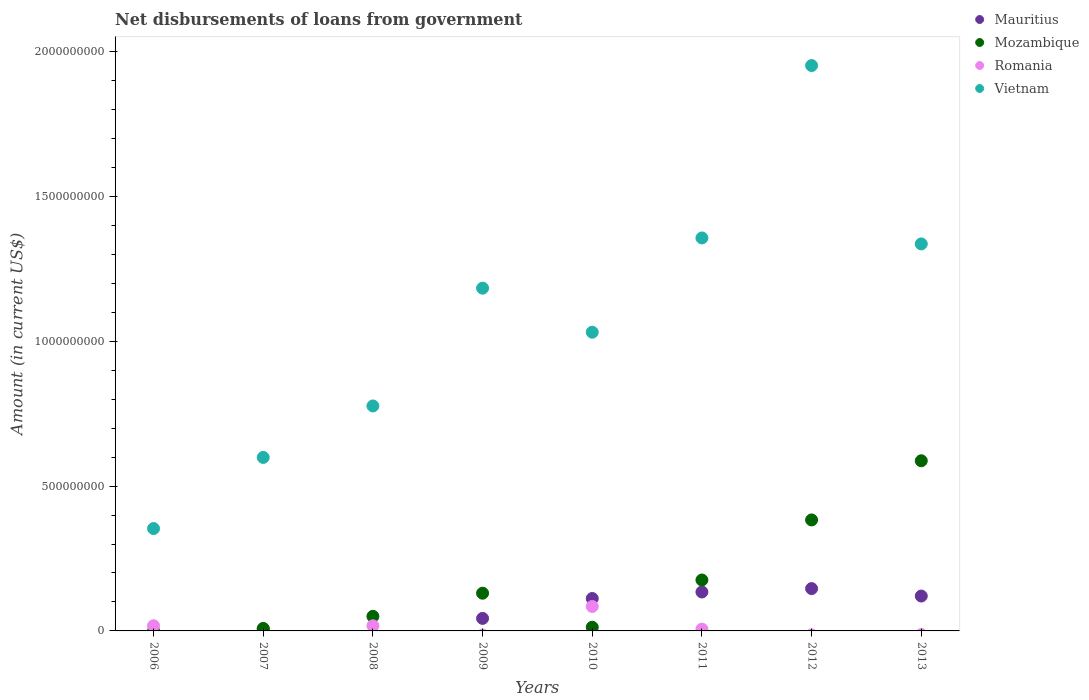What is the amount of loan disbursed from government in Vietnam in 2007?
Give a very brief answer. 5.99e+08. Across all years, what is the maximum amount of loan disbursed from government in Romania?
Offer a terse response. 8.44e+07. Across all years, what is the minimum amount of loan disbursed from government in Mozambique?
Give a very brief answer. 0. What is the total amount of loan disbursed from government in Romania in the graph?
Make the answer very short. 1.26e+08. What is the difference between the amount of loan disbursed from government in Vietnam in 2009 and that in 2011?
Give a very brief answer. -1.73e+08. What is the difference between the amount of loan disbursed from government in Vietnam in 2013 and the amount of loan disbursed from government in Romania in 2008?
Offer a terse response. 1.32e+09. What is the average amount of loan disbursed from government in Mozambique per year?
Keep it short and to the point. 1.69e+08. In the year 2006, what is the difference between the amount of loan disbursed from government in Vietnam and amount of loan disbursed from government in Romania?
Ensure brevity in your answer.  3.36e+08. In how many years, is the amount of loan disbursed from government in Mozambique greater than 600000000 US$?
Provide a succinct answer. 0. What is the ratio of the amount of loan disbursed from government in Vietnam in 2008 to that in 2009?
Offer a very short reply. 0.66. What is the difference between the highest and the second highest amount of loan disbursed from government in Mauritius?
Your answer should be compact. 1.17e+07. What is the difference between the highest and the lowest amount of loan disbursed from government in Mozambique?
Give a very brief answer. 5.87e+08. In how many years, is the amount of loan disbursed from government in Mauritius greater than the average amount of loan disbursed from government in Mauritius taken over all years?
Offer a very short reply. 4. Is it the case that in every year, the sum of the amount of loan disbursed from government in Mauritius and amount of loan disbursed from government in Mozambique  is greater than the sum of amount of loan disbursed from government in Romania and amount of loan disbursed from government in Vietnam?
Your answer should be very brief. No. Is the amount of loan disbursed from government in Mauritius strictly greater than the amount of loan disbursed from government in Mozambique over the years?
Offer a terse response. No. How many dotlines are there?
Provide a succinct answer. 4. How many years are there in the graph?
Provide a short and direct response. 8. Are the values on the major ticks of Y-axis written in scientific E-notation?
Keep it short and to the point. No. How many legend labels are there?
Your answer should be very brief. 4. How are the legend labels stacked?
Keep it short and to the point. Vertical. What is the title of the graph?
Offer a very short reply. Net disbursements of loans from government. Does "Northern Mariana Islands" appear as one of the legend labels in the graph?
Keep it short and to the point. No. What is the Amount (in current US$) in Mauritius in 2006?
Provide a short and direct response. 0. What is the Amount (in current US$) in Romania in 2006?
Offer a very short reply. 1.79e+07. What is the Amount (in current US$) in Vietnam in 2006?
Ensure brevity in your answer.  3.53e+08. What is the Amount (in current US$) in Mauritius in 2007?
Your answer should be very brief. 6.59e+06. What is the Amount (in current US$) of Mozambique in 2007?
Your answer should be very brief. 8.58e+06. What is the Amount (in current US$) of Vietnam in 2007?
Your answer should be very brief. 5.99e+08. What is the Amount (in current US$) of Mozambique in 2008?
Provide a succinct answer. 5.03e+07. What is the Amount (in current US$) in Romania in 2008?
Your answer should be very brief. 1.78e+07. What is the Amount (in current US$) of Vietnam in 2008?
Give a very brief answer. 7.77e+08. What is the Amount (in current US$) in Mauritius in 2009?
Keep it short and to the point. 4.32e+07. What is the Amount (in current US$) of Mozambique in 2009?
Your response must be concise. 1.30e+08. What is the Amount (in current US$) in Romania in 2009?
Your answer should be compact. 0. What is the Amount (in current US$) in Vietnam in 2009?
Your answer should be compact. 1.18e+09. What is the Amount (in current US$) of Mauritius in 2010?
Provide a short and direct response. 1.12e+08. What is the Amount (in current US$) in Mozambique in 2010?
Ensure brevity in your answer.  1.27e+07. What is the Amount (in current US$) in Romania in 2010?
Offer a terse response. 8.44e+07. What is the Amount (in current US$) in Vietnam in 2010?
Provide a short and direct response. 1.03e+09. What is the Amount (in current US$) of Mauritius in 2011?
Provide a short and direct response. 1.34e+08. What is the Amount (in current US$) in Mozambique in 2011?
Provide a short and direct response. 1.76e+08. What is the Amount (in current US$) in Romania in 2011?
Provide a succinct answer. 6.24e+06. What is the Amount (in current US$) in Vietnam in 2011?
Provide a succinct answer. 1.36e+09. What is the Amount (in current US$) in Mauritius in 2012?
Your answer should be very brief. 1.46e+08. What is the Amount (in current US$) of Mozambique in 2012?
Give a very brief answer. 3.83e+08. What is the Amount (in current US$) in Vietnam in 2012?
Give a very brief answer. 1.95e+09. What is the Amount (in current US$) of Mauritius in 2013?
Keep it short and to the point. 1.20e+08. What is the Amount (in current US$) of Mozambique in 2013?
Make the answer very short. 5.87e+08. What is the Amount (in current US$) in Romania in 2013?
Your response must be concise. 0. What is the Amount (in current US$) of Vietnam in 2013?
Provide a short and direct response. 1.34e+09. Across all years, what is the maximum Amount (in current US$) in Mauritius?
Provide a succinct answer. 1.46e+08. Across all years, what is the maximum Amount (in current US$) of Mozambique?
Ensure brevity in your answer.  5.87e+08. Across all years, what is the maximum Amount (in current US$) in Romania?
Your response must be concise. 8.44e+07. Across all years, what is the maximum Amount (in current US$) of Vietnam?
Keep it short and to the point. 1.95e+09. Across all years, what is the minimum Amount (in current US$) of Mozambique?
Keep it short and to the point. 0. Across all years, what is the minimum Amount (in current US$) in Vietnam?
Provide a succinct answer. 3.53e+08. What is the total Amount (in current US$) in Mauritius in the graph?
Offer a very short reply. 5.63e+08. What is the total Amount (in current US$) of Mozambique in the graph?
Ensure brevity in your answer.  1.35e+09. What is the total Amount (in current US$) of Romania in the graph?
Your answer should be compact. 1.26e+08. What is the total Amount (in current US$) of Vietnam in the graph?
Make the answer very short. 8.59e+09. What is the difference between the Amount (in current US$) of Vietnam in 2006 and that in 2007?
Offer a very short reply. -2.46e+08. What is the difference between the Amount (in current US$) in Romania in 2006 and that in 2008?
Your response must be concise. 7.40e+04. What is the difference between the Amount (in current US$) of Vietnam in 2006 and that in 2008?
Your answer should be very brief. -4.23e+08. What is the difference between the Amount (in current US$) of Vietnam in 2006 and that in 2009?
Give a very brief answer. -8.30e+08. What is the difference between the Amount (in current US$) in Romania in 2006 and that in 2010?
Your response must be concise. -6.65e+07. What is the difference between the Amount (in current US$) in Vietnam in 2006 and that in 2010?
Provide a succinct answer. -6.78e+08. What is the difference between the Amount (in current US$) in Romania in 2006 and that in 2011?
Give a very brief answer. 1.16e+07. What is the difference between the Amount (in current US$) of Vietnam in 2006 and that in 2011?
Ensure brevity in your answer.  -1.00e+09. What is the difference between the Amount (in current US$) of Vietnam in 2006 and that in 2012?
Provide a succinct answer. -1.60e+09. What is the difference between the Amount (in current US$) of Vietnam in 2006 and that in 2013?
Give a very brief answer. -9.83e+08. What is the difference between the Amount (in current US$) in Mozambique in 2007 and that in 2008?
Give a very brief answer. -4.17e+07. What is the difference between the Amount (in current US$) of Vietnam in 2007 and that in 2008?
Your answer should be very brief. -1.78e+08. What is the difference between the Amount (in current US$) in Mauritius in 2007 and that in 2009?
Provide a succinct answer. -3.67e+07. What is the difference between the Amount (in current US$) in Mozambique in 2007 and that in 2009?
Offer a very short reply. -1.22e+08. What is the difference between the Amount (in current US$) of Vietnam in 2007 and that in 2009?
Offer a terse response. -5.84e+08. What is the difference between the Amount (in current US$) in Mauritius in 2007 and that in 2010?
Offer a terse response. -1.05e+08. What is the difference between the Amount (in current US$) in Mozambique in 2007 and that in 2010?
Provide a short and direct response. -4.10e+06. What is the difference between the Amount (in current US$) of Vietnam in 2007 and that in 2010?
Ensure brevity in your answer.  -4.32e+08. What is the difference between the Amount (in current US$) in Mauritius in 2007 and that in 2011?
Keep it short and to the point. -1.28e+08. What is the difference between the Amount (in current US$) in Mozambique in 2007 and that in 2011?
Offer a very short reply. -1.67e+08. What is the difference between the Amount (in current US$) in Vietnam in 2007 and that in 2011?
Keep it short and to the point. -7.58e+08. What is the difference between the Amount (in current US$) of Mauritius in 2007 and that in 2012?
Provide a short and direct response. -1.40e+08. What is the difference between the Amount (in current US$) of Mozambique in 2007 and that in 2012?
Provide a succinct answer. -3.75e+08. What is the difference between the Amount (in current US$) in Vietnam in 2007 and that in 2012?
Provide a short and direct response. -1.35e+09. What is the difference between the Amount (in current US$) of Mauritius in 2007 and that in 2013?
Your answer should be very brief. -1.14e+08. What is the difference between the Amount (in current US$) in Mozambique in 2007 and that in 2013?
Offer a very short reply. -5.79e+08. What is the difference between the Amount (in current US$) of Vietnam in 2007 and that in 2013?
Your answer should be compact. -7.37e+08. What is the difference between the Amount (in current US$) of Mozambique in 2008 and that in 2009?
Your answer should be very brief. -7.99e+07. What is the difference between the Amount (in current US$) in Vietnam in 2008 and that in 2009?
Make the answer very short. -4.07e+08. What is the difference between the Amount (in current US$) of Mozambique in 2008 and that in 2010?
Offer a very short reply. 3.76e+07. What is the difference between the Amount (in current US$) of Romania in 2008 and that in 2010?
Offer a terse response. -6.66e+07. What is the difference between the Amount (in current US$) in Vietnam in 2008 and that in 2010?
Offer a terse response. -2.55e+08. What is the difference between the Amount (in current US$) in Mozambique in 2008 and that in 2011?
Your answer should be compact. -1.26e+08. What is the difference between the Amount (in current US$) of Romania in 2008 and that in 2011?
Your answer should be very brief. 1.15e+07. What is the difference between the Amount (in current US$) in Vietnam in 2008 and that in 2011?
Your answer should be very brief. -5.80e+08. What is the difference between the Amount (in current US$) in Mozambique in 2008 and that in 2012?
Your answer should be very brief. -3.33e+08. What is the difference between the Amount (in current US$) in Vietnam in 2008 and that in 2012?
Provide a short and direct response. -1.18e+09. What is the difference between the Amount (in current US$) in Mozambique in 2008 and that in 2013?
Offer a very short reply. -5.37e+08. What is the difference between the Amount (in current US$) of Vietnam in 2008 and that in 2013?
Your response must be concise. -5.59e+08. What is the difference between the Amount (in current US$) in Mauritius in 2009 and that in 2010?
Give a very brief answer. -6.87e+07. What is the difference between the Amount (in current US$) of Mozambique in 2009 and that in 2010?
Provide a short and direct response. 1.18e+08. What is the difference between the Amount (in current US$) in Vietnam in 2009 and that in 2010?
Offer a terse response. 1.52e+08. What is the difference between the Amount (in current US$) of Mauritius in 2009 and that in 2011?
Give a very brief answer. -9.11e+07. What is the difference between the Amount (in current US$) of Mozambique in 2009 and that in 2011?
Keep it short and to the point. -4.56e+07. What is the difference between the Amount (in current US$) of Vietnam in 2009 and that in 2011?
Make the answer very short. -1.73e+08. What is the difference between the Amount (in current US$) in Mauritius in 2009 and that in 2012?
Your response must be concise. -1.03e+08. What is the difference between the Amount (in current US$) of Mozambique in 2009 and that in 2012?
Your answer should be compact. -2.53e+08. What is the difference between the Amount (in current US$) of Vietnam in 2009 and that in 2012?
Give a very brief answer. -7.69e+08. What is the difference between the Amount (in current US$) in Mauritius in 2009 and that in 2013?
Keep it short and to the point. -7.72e+07. What is the difference between the Amount (in current US$) in Mozambique in 2009 and that in 2013?
Keep it short and to the point. -4.57e+08. What is the difference between the Amount (in current US$) in Vietnam in 2009 and that in 2013?
Your answer should be very brief. -1.53e+08. What is the difference between the Amount (in current US$) in Mauritius in 2010 and that in 2011?
Give a very brief answer. -2.24e+07. What is the difference between the Amount (in current US$) of Mozambique in 2010 and that in 2011?
Give a very brief answer. -1.63e+08. What is the difference between the Amount (in current US$) in Romania in 2010 and that in 2011?
Provide a succinct answer. 7.82e+07. What is the difference between the Amount (in current US$) in Vietnam in 2010 and that in 2011?
Your answer should be compact. -3.25e+08. What is the difference between the Amount (in current US$) of Mauritius in 2010 and that in 2012?
Your answer should be compact. -3.41e+07. What is the difference between the Amount (in current US$) of Mozambique in 2010 and that in 2012?
Your answer should be compact. -3.71e+08. What is the difference between the Amount (in current US$) of Vietnam in 2010 and that in 2012?
Ensure brevity in your answer.  -9.21e+08. What is the difference between the Amount (in current US$) of Mauritius in 2010 and that in 2013?
Offer a very short reply. -8.45e+06. What is the difference between the Amount (in current US$) in Mozambique in 2010 and that in 2013?
Ensure brevity in your answer.  -5.75e+08. What is the difference between the Amount (in current US$) in Vietnam in 2010 and that in 2013?
Offer a very short reply. -3.05e+08. What is the difference between the Amount (in current US$) of Mauritius in 2011 and that in 2012?
Provide a short and direct response. -1.17e+07. What is the difference between the Amount (in current US$) of Mozambique in 2011 and that in 2012?
Offer a very short reply. -2.07e+08. What is the difference between the Amount (in current US$) of Vietnam in 2011 and that in 2012?
Make the answer very short. -5.95e+08. What is the difference between the Amount (in current US$) in Mauritius in 2011 and that in 2013?
Offer a very short reply. 1.40e+07. What is the difference between the Amount (in current US$) of Mozambique in 2011 and that in 2013?
Provide a succinct answer. -4.12e+08. What is the difference between the Amount (in current US$) in Vietnam in 2011 and that in 2013?
Offer a very short reply. 2.06e+07. What is the difference between the Amount (in current US$) of Mauritius in 2012 and that in 2013?
Give a very brief answer. 2.57e+07. What is the difference between the Amount (in current US$) in Mozambique in 2012 and that in 2013?
Offer a terse response. -2.04e+08. What is the difference between the Amount (in current US$) of Vietnam in 2012 and that in 2013?
Offer a terse response. 6.16e+08. What is the difference between the Amount (in current US$) in Romania in 2006 and the Amount (in current US$) in Vietnam in 2007?
Your answer should be very brief. -5.81e+08. What is the difference between the Amount (in current US$) in Romania in 2006 and the Amount (in current US$) in Vietnam in 2008?
Ensure brevity in your answer.  -7.59e+08. What is the difference between the Amount (in current US$) of Romania in 2006 and the Amount (in current US$) of Vietnam in 2009?
Provide a short and direct response. -1.17e+09. What is the difference between the Amount (in current US$) in Romania in 2006 and the Amount (in current US$) in Vietnam in 2010?
Offer a very short reply. -1.01e+09. What is the difference between the Amount (in current US$) in Romania in 2006 and the Amount (in current US$) in Vietnam in 2011?
Make the answer very short. -1.34e+09. What is the difference between the Amount (in current US$) in Romania in 2006 and the Amount (in current US$) in Vietnam in 2012?
Your answer should be compact. -1.93e+09. What is the difference between the Amount (in current US$) in Romania in 2006 and the Amount (in current US$) in Vietnam in 2013?
Make the answer very short. -1.32e+09. What is the difference between the Amount (in current US$) in Mauritius in 2007 and the Amount (in current US$) in Mozambique in 2008?
Your response must be concise. -4.37e+07. What is the difference between the Amount (in current US$) of Mauritius in 2007 and the Amount (in current US$) of Romania in 2008?
Keep it short and to the point. -1.12e+07. What is the difference between the Amount (in current US$) of Mauritius in 2007 and the Amount (in current US$) of Vietnam in 2008?
Offer a very short reply. -7.70e+08. What is the difference between the Amount (in current US$) of Mozambique in 2007 and the Amount (in current US$) of Romania in 2008?
Provide a short and direct response. -9.20e+06. What is the difference between the Amount (in current US$) of Mozambique in 2007 and the Amount (in current US$) of Vietnam in 2008?
Provide a succinct answer. -7.68e+08. What is the difference between the Amount (in current US$) in Mauritius in 2007 and the Amount (in current US$) in Mozambique in 2009?
Ensure brevity in your answer.  -1.24e+08. What is the difference between the Amount (in current US$) of Mauritius in 2007 and the Amount (in current US$) of Vietnam in 2009?
Your answer should be very brief. -1.18e+09. What is the difference between the Amount (in current US$) in Mozambique in 2007 and the Amount (in current US$) in Vietnam in 2009?
Provide a succinct answer. -1.17e+09. What is the difference between the Amount (in current US$) in Mauritius in 2007 and the Amount (in current US$) in Mozambique in 2010?
Ensure brevity in your answer.  -6.09e+06. What is the difference between the Amount (in current US$) in Mauritius in 2007 and the Amount (in current US$) in Romania in 2010?
Your answer should be very brief. -7.78e+07. What is the difference between the Amount (in current US$) in Mauritius in 2007 and the Amount (in current US$) in Vietnam in 2010?
Offer a terse response. -1.02e+09. What is the difference between the Amount (in current US$) in Mozambique in 2007 and the Amount (in current US$) in Romania in 2010?
Offer a very short reply. -7.58e+07. What is the difference between the Amount (in current US$) in Mozambique in 2007 and the Amount (in current US$) in Vietnam in 2010?
Your response must be concise. -1.02e+09. What is the difference between the Amount (in current US$) of Mauritius in 2007 and the Amount (in current US$) of Mozambique in 2011?
Keep it short and to the point. -1.69e+08. What is the difference between the Amount (in current US$) in Mauritius in 2007 and the Amount (in current US$) in Romania in 2011?
Your response must be concise. 3.56e+05. What is the difference between the Amount (in current US$) in Mauritius in 2007 and the Amount (in current US$) in Vietnam in 2011?
Ensure brevity in your answer.  -1.35e+09. What is the difference between the Amount (in current US$) of Mozambique in 2007 and the Amount (in current US$) of Romania in 2011?
Give a very brief answer. 2.35e+06. What is the difference between the Amount (in current US$) in Mozambique in 2007 and the Amount (in current US$) in Vietnam in 2011?
Give a very brief answer. -1.35e+09. What is the difference between the Amount (in current US$) in Mauritius in 2007 and the Amount (in current US$) in Mozambique in 2012?
Offer a terse response. -3.77e+08. What is the difference between the Amount (in current US$) in Mauritius in 2007 and the Amount (in current US$) in Vietnam in 2012?
Give a very brief answer. -1.95e+09. What is the difference between the Amount (in current US$) of Mozambique in 2007 and the Amount (in current US$) of Vietnam in 2012?
Ensure brevity in your answer.  -1.94e+09. What is the difference between the Amount (in current US$) in Mauritius in 2007 and the Amount (in current US$) in Mozambique in 2013?
Give a very brief answer. -5.81e+08. What is the difference between the Amount (in current US$) of Mauritius in 2007 and the Amount (in current US$) of Vietnam in 2013?
Offer a very short reply. -1.33e+09. What is the difference between the Amount (in current US$) in Mozambique in 2007 and the Amount (in current US$) in Vietnam in 2013?
Make the answer very short. -1.33e+09. What is the difference between the Amount (in current US$) of Mozambique in 2008 and the Amount (in current US$) of Vietnam in 2009?
Make the answer very short. -1.13e+09. What is the difference between the Amount (in current US$) of Romania in 2008 and the Amount (in current US$) of Vietnam in 2009?
Provide a succinct answer. -1.17e+09. What is the difference between the Amount (in current US$) of Mozambique in 2008 and the Amount (in current US$) of Romania in 2010?
Give a very brief answer. -3.41e+07. What is the difference between the Amount (in current US$) in Mozambique in 2008 and the Amount (in current US$) in Vietnam in 2010?
Your answer should be compact. -9.81e+08. What is the difference between the Amount (in current US$) of Romania in 2008 and the Amount (in current US$) of Vietnam in 2010?
Your answer should be compact. -1.01e+09. What is the difference between the Amount (in current US$) in Mozambique in 2008 and the Amount (in current US$) in Romania in 2011?
Ensure brevity in your answer.  4.41e+07. What is the difference between the Amount (in current US$) in Mozambique in 2008 and the Amount (in current US$) in Vietnam in 2011?
Offer a terse response. -1.31e+09. What is the difference between the Amount (in current US$) in Romania in 2008 and the Amount (in current US$) in Vietnam in 2011?
Give a very brief answer. -1.34e+09. What is the difference between the Amount (in current US$) of Mozambique in 2008 and the Amount (in current US$) of Vietnam in 2012?
Your response must be concise. -1.90e+09. What is the difference between the Amount (in current US$) of Romania in 2008 and the Amount (in current US$) of Vietnam in 2012?
Provide a succinct answer. -1.93e+09. What is the difference between the Amount (in current US$) in Mozambique in 2008 and the Amount (in current US$) in Vietnam in 2013?
Make the answer very short. -1.29e+09. What is the difference between the Amount (in current US$) of Romania in 2008 and the Amount (in current US$) of Vietnam in 2013?
Provide a succinct answer. -1.32e+09. What is the difference between the Amount (in current US$) of Mauritius in 2009 and the Amount (in current US$) of Mozambique in 2010?
Your answer should be compact. 3.06e+07. What is the difference between the Amount (in current US$) of Mauritius in 2009 and the Amount (in current US$) of Romania in 2010?
Keep it short and to the point. -4.11e+07. What is the difference between the Amount (in current US$) of Mauritius in 2009 and the Amount (in current US$) of Vietnam in 2010?
Your answer should be very brief. -9.88e+08. What is the difference between the Amount (in current US$) in Mozambique in 2009 and the Amount (in current US$) in Romania in 2010?
Give a very brief answer. 4.58e+07. What is the difference between the Amount (in current US$) in Mozambique in 2009 and the Amount (in current US$) in Vietnam in 2010?
Your answer should be very brief. -9.01e+08. What is the difference between the Amount (in current US$) in Mauritius in 2009 and the Amount (in current US$) in Mozambique in 2011?
Make the answer very short. -1.33e+08. What is the difference between the Amount (in current US$) of Mauritius in 2009 and the Amount (in current US$) of Romania in 2011?
Ensure brevity in your answer.  3.70e+07. What is the difference between the Amount (in current US$) of Mauritius in 2009 and the Amount (in current US$) of Vietnam in 2011?
Offer a terse response. -1.31e+09. What is the difference between the Amount (in current US$) in Mozambique in 2009 and the Amount (in current US$) in Romania in 2011?
Provide a short and direct response. 1.24e+08. What is the difference between the Amount (in current US$) of Mozambique in 2009 and the Amount (in current US$) of Vietnam in 2011?
Provide a short and direct response. -1.23e+09. What is the difference between the Amount (in current US$) in Mauritius in 2009 and the Amount (in current US$) in Mozambique in 2012?
Provide a succinct answer. -3.40e+08. What is the difference between the Amount (in current US$) of Mauritius in 2009 and the Amount (in current US$) of Vietnam in 2012?
Ensure brevity in your answer.  -1.91e+09. What is the difference between the Amount (in current US$) in Mozambique in 2009 and the Amount (in current US$) in Vietnam in 2012?
Ensure brevity in your answer.  -1.82e+09. What is the difference between the Amount (in current US$) of Mauritius in 2009 and the Amount (in current US$) of Mozambique in 2013?
Keep it short and to the point. -5.44e+08. What is the difference between the Amount (in current US$) in Mauritius in 2009 and the Amount (in current US$) in Vietnam in 2013?
Ensure brevity in your answer.  -1.29e+09. What is the difference between the Amount (in current US$) of Mozambique in 2009 and the Amount (in current US$) of Vietnam in 2013?
Provide a succinct answer. -1.21e+09. What is the difference between the Amount (in current US$) of Mauritius in 2010 and the Amount (in current US$) of Mozambique in 2011?
Your answer should be very brief. -6.38e+07. What is the difference between the Amount (in current US$) in Mauritius in 2010 and the Amount (in current US$) in Romania in 2011?
Offer a very short reply. 1.06e+08. What is the difference between the Amount (in current US$) of Mauritius in 2010 and the Amount (in current US$) of Vietnam in 2011?
Your answer should be compact. -1.24e+09. What is the difference between the Amount (in current US$) in Mozambique in 2010 and the Amount (in current US$) in Romania in 2011?
Keep it short and to the point. 6.44e+06. What is the difference between the Amount (in current US$) in Mozambique in 2010 and the Amount (in current US$) in Vietnam in 2011?
Your answer should be very brief. -1.34e+09. What is the difference between the Amount (in current US$) of Romania in 2010 and the Amount (in current US$) of Vietnam in 2011?
Keep it short and to the point. -1.27e+09. What is the difference between the Amount (in current US$) in Mauritius in 2010 and the Amount (in current US$) in Mozambique in 2012?
Your response must be concise. -2.71e+08. What is the difference between the Amount (in current US$) in Mauritius in 2010 and the Amount (in current US$) in Vietnam in 2012?
Offer a terse response. -1.84e+09. What is the difference between the Amount (in current US$) in Mozambique in 2010 and the Amount (in current US$) in Vietnam in 2012?
Ensure brevity in your answer.  -1.94e+09. What is the difference between the Amount (in current US$) in Romania in 2010 and the Amount (in current US$) in Vietnam in 2012?
Your answer should be compact. -1.87e+09. What is the difference between the Amount (in current US$) in Mauritius in 2010 and the Amount (in current US$) in Mozambique in 2013?
Keep it short and to the point. -4.76e+08. What is the difference between the Amount (in current US$) in Mauritius in 2010 and the Amount (in current US$) in Vietnam in 2013?
Provide a succinct answer. -1.22e+09. What is the difference between the Amount (in current US$) in Mozambique in 2010 and the Amount (in current US$) in Vietnam in 2013?
Make the answer very short. -1.32e+09. What is the difference between the Amount (in current US$) in Romania in 2010 and the Amount (in current US$) in Vietnam in 2013?
Make the answer very short. -1.25e+09. What is the difference between the Amount (in current US$) in Mauritius in 2011 and the Amount (in current US$) in Mozambique in 2012?
Ensure brevity in your answer.  -2.49e+08. What is the difference between the Amount (in current US$) in Mauritius in 2011 and the Amount (in current US$) in Vietnam in 2012?
Keep it short and to the point. -1.82e+09. What is the difference between the Amount (in current US$) in Mozambique in 2011 and the Amount (in current US$) in Vietnam in 2012?
Offer a very short reply. -1.78e+09. What is the difference between the Amount (in current US$) in Romania in 2011 and the Amount (in current US$) in Vietnam in 2012?
Ensure brevity in your answer.  -1.95e+09. What is the difference between the Amount (in current US$) of Mauritius in 2011 and the Amount (in current US$) of Mozambique in 2013?
Give a very brief answer. -4.53e+08. What is the difference between the Amount (in current US$) of Mauritius in 2011 and the Amount (in current US$) of Vietnam in 2013?
Provide a short and direct response. -1.20e+09. What is the difference between the Amount (in current US$) in Mozambique in 2011 and the Amount (in current US$) in Vietnam in 2013?
Offer a terse response. -1.16e+09. What is the difference between the Amount (in current US$) in Romania in 2011 and the Amount (in current US$) in Vietnam in 2013?
Make the answer very short. -1.33e+09. What is the difference between the Amount (in current US$) in Mauritius in 2012 and the Amount (in current US$) in Mozambique in 2013?
Ensure brevity in your answer.  -4.41e+08. What is the difference between the Amount (in current US$) of Mauritius in 2012 and the Amount (in current US$) of Vietnam in 2013?
Make the answer very short. -1.19e+09. What is the difference between the Amount (in current US$) in Mozambique in 2012 and the Amount (in current US$) in Vietnam in 2013?
Keep it short and to the point. -9.53e+08. What is the average Amount (in current US$) in Mauritius per year?
Provide a short and direct response. 7.03e+07. What is the average Amount (in current US$) in Mozambique per year?
Give a very brief answer. 1.69e+08. What is the average Amount (in current US$) in Romania per year?
Give a very brief answer. 1.58e+07. What is the average Amount (in current US$) in Vietnam per year?
Provide a succinct answer. 1.07e+09. In the year 2006, what is the difference between the Amount (in current US$) in Romania and Amount (in current US$) in Vietnam?
Make the answer very short. -3.36e+08. In the year 2007, what is the difference between the Amount (in current US$) of Mauritius and Amount (in current US$) of Mozambique?
Provide a succinct answer. -1.99e+06. In the year 2007, what is the difference between the Amount (in current US$) in Mauritius and Amount (in current US$) in Vietnam?
Offer a very short reply. -5.92e+08. In the year 2007, what is the difference between the Amount (in current US$) of Mozambique and Amount (in current US$) of Vietnam?
Provide a short and direct response. -5.90e+08. In the year 2008, what is the difference between the Amount (in current US$) in Mozambique and Amount (in current US$) in Romania?
Keep it short and to the point. 3.25e+07. In the year 2008, what is the difference between the Amount (in current US$) of Mozambique and Amount (in current US$) of Vietnam?
Keep it short and to the point. -7.26e+08. In the year 2008, what is the difference between the Amount (in current US$) in Romania and Amount (in current US$) in Vietnam?
Offer a very short reply. -7.59e+08. In the year 2009, what is the difference between the Amount (in current US$) in Mauritius and Amount (in current US$) in Mozambique?
Give a very brief answer. -8.70e+07. In the year 2009, what is the difference between the Amount (in current US$) of Mauritius and Amount (in current US$) of Vietnam?
Offer a very short reply. -1.14e+09. In the year 2009, what is the difference between the Amount (in current US$) of Mozambique and Amount (in current US$) of Vietnam?
Give a very brief answer. -1.05e+09. In the year 2010, what is the difference between the Amount (in current US$) in Mauritius and Amount (in current US$) in Mozambique?
Offer a terse response. 9.93e+07. In the year 2010, what is the difference between the Amount (in current US$) of Mauritius and Amount (in current US$) of Romania?
Make the answer very short. 2.76e+07. In the year 2010, what is the difference between the Amount (in current US$) of Mauritius and Amount (in current US$) of Vietnam?
Provide a succinct answer. -9.19e+08. In the year 2010, what is the difference between the Amount (in current US$) in Mozambique and Amount (in current US$) in Romania?
Your response must be concise. -7.17e+07. In the year 2010, what is the difference between the Amount (in current US$) in Mozambique and Amount (in current US$) in Vietnam?
Offer a very short reply. -1.02e+09. In the year 2010, what is the difference between the Amount (in current US$) in Romania and Amount (in current US$) in Vietnam?
Your response must be concise. -9.47e+08. In the year 2011, what is the difference between the Amount (in current US$) of Mauritius and Amount (in current US$) of Mozambique?
Your response must be concise. -4.14e+07. In the year 2011, what is the difference between the Amount (in current US$) of Mauritius and Amount (in current US$) of Romania?
Make the answer very short. 1.28e+08. In the year 2011, what is the difference between the Amount (in current US$) in Mauritius and Amount (in current US$) in Vietnam?
Offer a terse response. -1.22e+09. In the year 2011, what is the difference between the Amount (in current US$) in Mozambique and Amount (in current US$) in Romania?
Offer a terse response. 1.70e+08. In the year 2011, what is the difference between the Amount (in current US$) in Mozambique and Amount (in current US$) in Vietnam?
Your answer should be very brief. -1.18e+09. In the year 2011, what is the difference between the Amount (in current US$) in Romania and Amount (in current US$) in Vietnam?
Make the answer very short. -1.35e+09. In the year 2012, what is the difference between the Amount (in current US$) in Mauritius and Amount (in current US$) in Mozambique?
Provide a succinct answer. -2.37e+08. In the year 2012, what is the difference between the Amount (in current US$) in Mauritius and Amount (in current US$) in Vietnam?
Your answer should be compact. -1.81e+09. In the year 2012, what is the difference between the Amount (in current US$) in Mozambique and Amount (in current US$) in Vietnam?
Make the answer very short. -1.57e+09. In the year 2013, what is the difference between the Amount (in current US$) in Mauritius and Amount (in current US$) in Mozambique?
Offer a terse response. -4.67e+08. In the year 2013, what is the difference between the Amount (in current US$) of Mauritius and Amount (in current US$) of Vietnam?
Ensure brevity in your answer.  -1.22e+09. In the year 2013, what is the difference between the Amount (in current US$) of Mozambique and Amount (in current US$) of Vietnam?
Keep it short and to the point. -7.49e+08. What is the ratio of the Amount (in current US$) in Vietnam in 2006 to that in 2007?
Provide a succinct answer. 0.59. What is the ratio of the Amount (in current US$) in Vietnam in 2006 to that in 2008?
Give a very brief answer. 0.46. What is the ratio of the Amount (in current US$) in Vietnam in 2006 to that in 2009?
Offer a terse response. 0.3. What is the ratio of the Amount (in current US$) of Romania in 2006 to that in 2010?
Provide a succinct answer. 0.21. What is the ratio of the Amount (in current US$) in Vietnam in 2006 to that in 2010?
Offer a very short reply. 0.34. What is the ratio of the Amount (in current US$) in Romania in 2006 to that in 2011?
Your response must be concise. 2.86. What is the ratio of the Amount (in current US$) in Vietnam in 2006 to that in 2011?
Ensure brevity in your answer.  0.26. What is the ratio of the Amount (in current US$) of Vietnam in 2006 to that in 2012?
Offer a terse response. 0.18. What is the ratio of the Amount (in current US$) of Vietnam in 2006 to that in 2013?
Give a very brief answer. 0.26. What is the ratio of the Amount (in current US$) of Mozambique in 2007 to that in 2008?
Your answer should be very brief. 0.17. What is the ratio of the Amount (in current US$) in Vietnam in 2007 to that in 2008?
Make the answer very short. 0.77. What is the ratio of the Amount (in current US$) of Mauritius in 2007 to that in 2009?
Your response must be concise. 0.15. What is the ratio of the Amount (in current US$) in Mozambique in 2007 to that in 2009?
Your response must be concise. 0.07. What is the ratio of the Amount (in current US$) in Vietnam in 2007 to that in 2009?
Keep it short and to the point. 0.51. What is the ratio of the Amount (in current US$) of Mauritius in 2007 to that in 2010?
Your answer should be very brief. 0.06. What is the ratio of the Amount (in current US$) of Mozambique in 2007 to that in 2010?
Make the answer very short. 0.68. What is the ratio of the Amount (in current US$) of Vietnam in 2007 to that in 2010?
Your answer should be very brief. 0.58. What is the ratio of the Amount (in current US$) of Mauritius in 2007 to that in 2011?
Ensure brevity in your answer.  0.05. What is the ratio of the Amount (in current US$) in Mozambique in 2007 to that in 2011?
Provide a succinct answer. 0.05. What is the ratio of the Amount (in current US$) of Vietnam in 2007 to that in 2011?
Give a very brief answer. 0.44. What is the ratio of the Amount (in current US$) of Mauritius in 2007 to that in 2012?
Keep it short and to the point. 0.05. What is the ratio of the Amount (in current US$) in Mozambique in 2007 to that in 2012?
Your answer should be compact. 0.02. What is the ratio of the Amount (in current US$) of Vietnam in 2007 to that in 2012?
Ensure brevity in your answer.  0.31. What is the ratio of the Amount (in current US$) in Mauritius in 2007 to that in 2013?
Provide a short and direct response. 0.05. What is the ratio of the Amount (in current US$) in Mozambique in 2007 to that in 2013?
Ensure brevity in your answer.  0.01. What is the ratio of the Amount (in current US$) in Vietnam in 2007 to that in 2013?
Provide a succinct answer. 0.45. What is the ratio of the Amount (in current US$) in Mozambique in 2008 to that in 2009?
Your answer should be compact. 0.39. What is the ratio of the Amount (in current US$) in Vietnam in 2008 to that in 2009?
Give a very brief answer. 0.66. What is the ratio of the Amount (in current US$) of Mozambique in 2008 to that in 2010?
Keep it short and to the point. 3.97. What is the ratio of the Amount (in current US$) of Romania in 2008 to that in 2010?
Ensure brevity in your answer.  0.21. What is the ratio of the Amount (in current US$) of Vietnam in 2008 to that in 2010?
Make the answer very short. 0.75. What is the ratio of the Amount (in current US$) of Mozambique in 2008 to that in 2011?
Your response must be concise. 0.29. What is the ratio of the Amount (in current US$) of Romania in 2008 to that in 2011?
Provide a short and direct response. 2.85. What is the ratio of the Amount (in current US$) in Vietnam in 2008 to that in 2011?
Offer a very short reply. 0.57. What is the ratio of the Amount (in current US$) of Mozambique in 2008 to that in 2012?
Provide a succinct answer. 0.13. What is the ratio of the Amount (in current US$) of Vietnam in 2008 to that in 2012?
Offer a very short reply. 0.4. What is the ratio of the Amount (in current US$) in Mozambique in 2008 to that in 2013?
Offer a terse response. 0.09. What is the ratio of the Amount (in current US$) of Vietnam in 2008 to that in 2013?
Offer a very short reply. 0.58. What is the ratio of the Amount (in current US$) of Mauritius in 2009 to that in 2010?
Your answer should be very brief. 0.39. What is the ratio of the Amount (in current US$) in Mozambique in 2009 to that in 2010?
Provide a succinct answer. 10.27. What is the ratio of the Amount (in current US$) in Vietnam in 2009 to that in 2010?
Your answer should be very brief. 1.15. What is the ratio of the Amount (in current US$) in Mauritius in 2009 to that in 2011?
Your answer should be very brief. 0.32. What is the ratio of the Amount (in current US$) of Mozambique in 2009 to that in 2011?
Offer a terse response. 0.74. What is the ratio of the Amount (in current US$) in Vietnam in 2009 to that in 2011?
Ensure brevity in your answer.  0.87. What is the ratio of the Amount (in current US$) of Mauritius in 2009 to that in 2012?
Offer a very short reply. 0.3. What is the ratio of the Amount (in current US$) in Mozambique in 2009 to that in 2012?
Keep it short and to the point. 0.34. What is the ratio of the Amount (in current US$) of Vietnam in 2009 to that in 2012?
Your answer should be very brief. 0.61. What is the ratio of the Amount (in current US$) of Mauritius in 2009 to that in 2013?
Offer a terse response. 0.36. What is the ratio of the Amount (in current US$) in Mozambique in 2009 to that in 2013?
Your answer should be very brief. 0.22. What is the ratio of the Amount (in current US$) in Vietnam in 2009 to that in 2013?
Keep it short and to the point. 0.89. What is the ratio of the Amount (in current US$) of Mauritius in 2010 to that in 2011?
Your response must be concise. 0.83. What is the ratio of the Amount (in current US$) of Mozambique in 2010 to that in 2011?
Provide a succinct answer. 0.07. What is the ratio of the Amount (in current US$) in Romania in 2010 to that in 2011?
Ensure brevity in your answer.  13.53. What is the ratio of the Amount (in current US$) in Vietnam in 2010 to that in 2011?
Your response must be concise. 0.76. What is the ratio of the Amount (in current US$) of Mauritius in 2010 to that in 2012?
Provide a succinct answer. 0.77. What is the ratio of the Amount (in current US$) of Mozambique in 2010 to that in 2012?
Offer a terse response. 0.03. What is the ratio of the Amount (in current US$) in Vietnam in 2010 to that in 2012?
Your response must be concise. 0.53. What is the ratio of the Amount (in current US$) in Mauritius in 2010 to that in 2013?
Provide a succinct answer. 0.93. What is the ratio of the Amount (in current US$) in Mozambique in 2010 to that in 2013?
Provide a succinct answer. 0.02. What is the ratio of the Amount (in current US$) in Vietnam in 2010 to that in 2013?
Your response must be concise. 0.77. What is the ratio of the Amount (in current US$) of Mauritius in 2011 to that in 2012?
Keep it short and to the point. 0.92. What is the ratio of the Amount (in current US$) in Mozambique in 2011 to that in 2012?
Keep it short and to the point. 0.46. What is the ratio of the Amount (in current US$) of Vietnam in 2011 to that in 2012?
Offer a terse response. 0.7. What is the ratio of the Amount (in current US$) of Mauritius in 2011 to that in 2013?
Ensure brevity in your answer.  1.12. What is the ratio of the Amount (in current US$) in Mozambique in 2011 to that in 2013?
Provide a succinct answer. 0.3. What is the ratio of the Amount (in current US$) in Vietnam in 2011 to that in 2013?
Give a very brief answer. 1.02. What is the ratio of the Amount (in current US$) in Mauritius in 2012 to that in 2013?
Make the answer very short. 1.21. What is the ratio of the Amount (in current US$) in Mozambique in 2012 to that in 2013?
Your answer should be very brief. 0.65. What is the ratio of the Amount (in current US$) in Vietnam in 2012 to that in 2013?
Your response must be concise. 1.46. What is the difference between the highest and the second highest Amount (in current US$) of Mauritius?
Your answer should be compact. 1.17e+07. What is the difference between the highest and the second highest Amount (in current US$) in Mozambique?
Ensure brevity in your answer.  2.04e+08. What is the difference between the highest and the second highest Amount (in current US$) of Romania?
Your answer should be compact. 6.65e+07. What is the difference between the highest and the second highest Amount (in current US$) in Vietnam?
Ensure brevity in your answer.  5.95e+08. What is the difference between the highest and the lowest Amount (in current US$) in Mauritius?
Provide a succinct answer. 1.46e+08. What is the difference between the highest and the lowest Amount (in current US$) of Mozambique?
Your answer should be very brief. 5.87e+08. What is the difference between the highest and the lowest Amount (in current US$) in Romania?
Ensure brevity in your answer.  8.44e+07. What is the difference between the highest and the lowest Amount (in current US$) in Vietnam?
Give a very brief answer. 1.60e+09. 